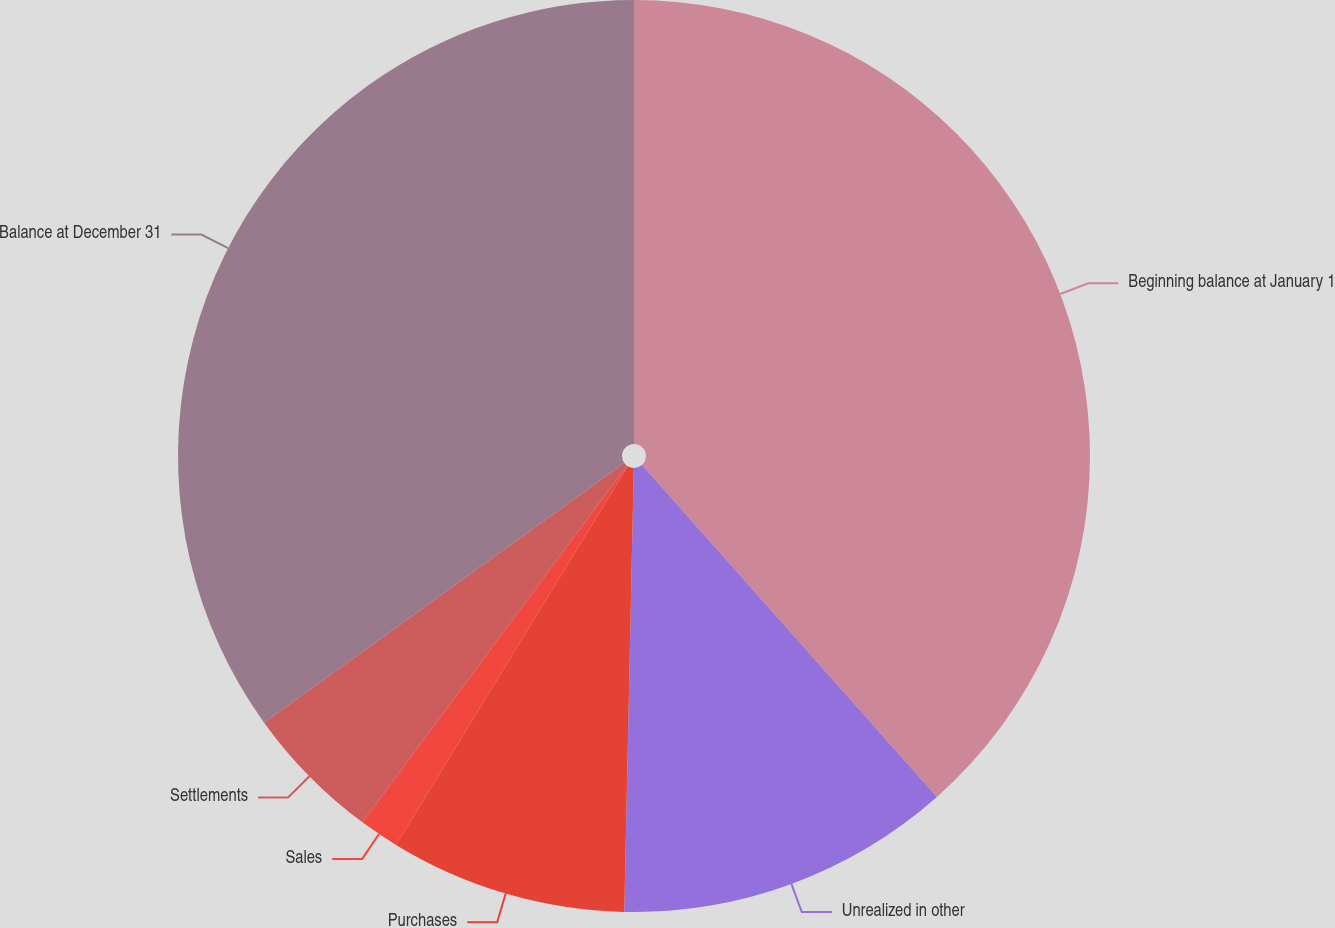Convert chart to OTSL. <chart><loc_0><loc_0><loc_500><loc_500><pie_chart><fcel>Beginning balance at January 1<fcel>Unrealized in other<fcel>Purchases<fcel>Sales<fcel>Settlements<fcel>Balance at December 31<nl><fcel>38.44%<fcel>11.9%<fcel>8.4%<fcel>1.41%<fcel>4.91%<fcel>34.94%<nl></chart> 